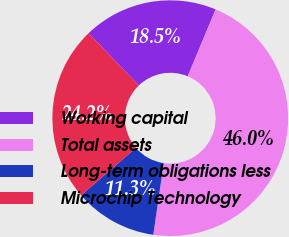Convert chart. <chart><loc_0><loc_0><loc_500><loc_500><pie_chart><fcel>Working capital<fcel>Total assets<fcel>Long-term obligations less<fcel>Microchip Technology<nl><fcel>18.48%<fcel>46.02%<fcel>11.35%<fcel>24.16%<nl></chart> 